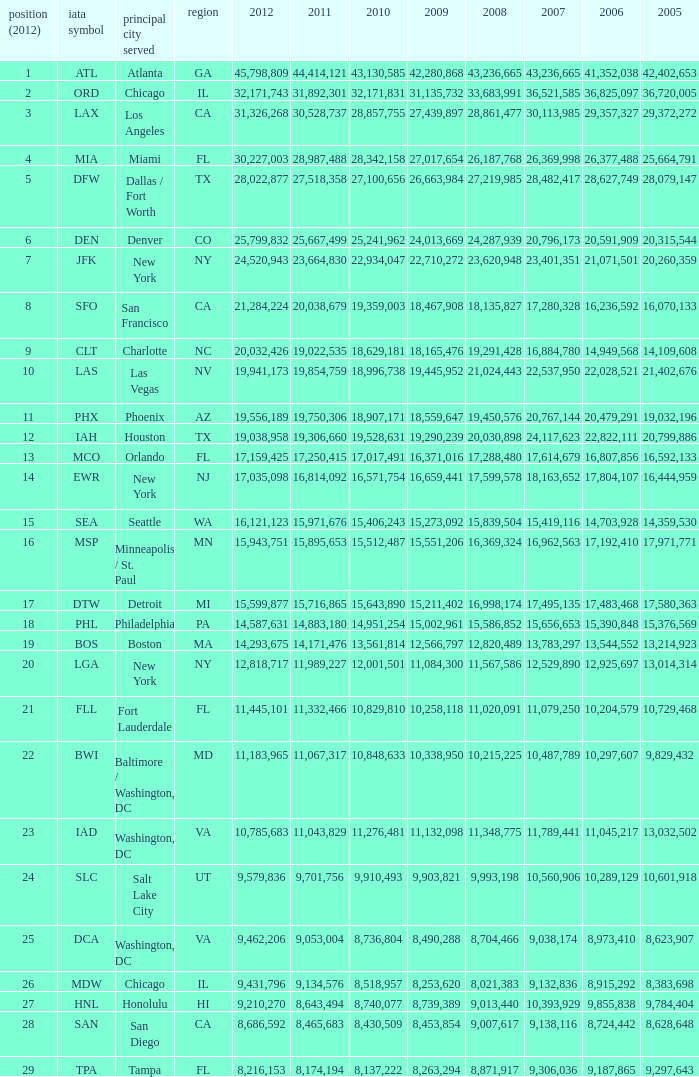When Philadelphia has a 2007 less than 20,796,173 and a 2008 more than 10,215,225, what is the smallest 2009? 15002961.0. 